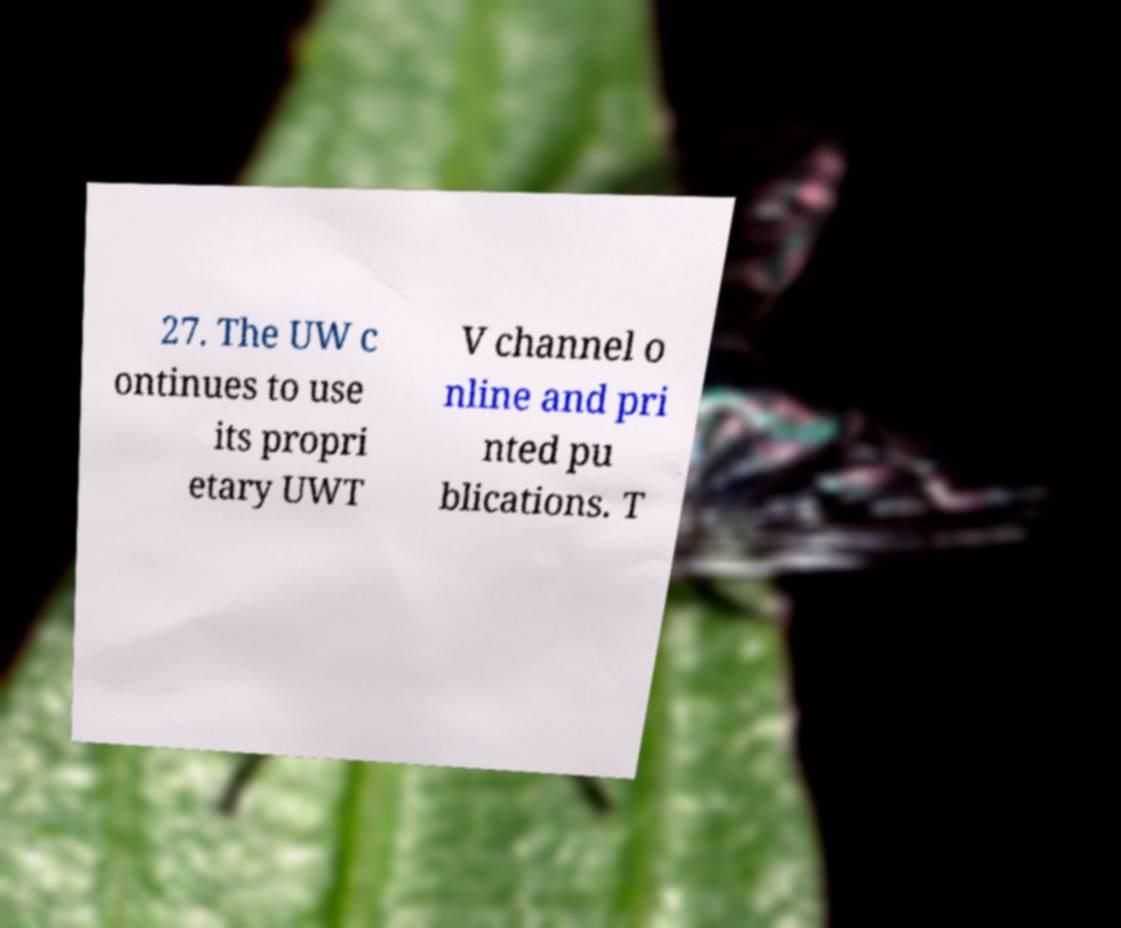What messages or text are displayed in this image? I need them in a readable, typed format. 27. The UW c ontinues to use its propri etary UWT V channel o nline and pri nted pu blications. T 